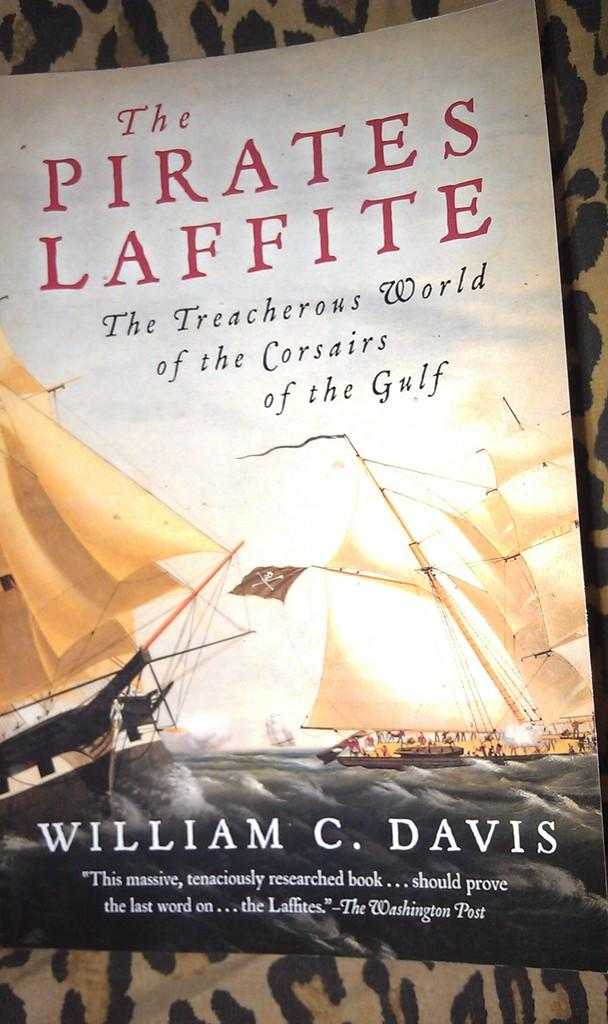<image>
Offer a succinct explanation of the picture presented. A book called the Pirates Laffite by William C. Davis. 